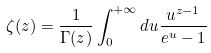<formula> <loc_0><loc_0><loc_500><loc_500>\zeta ( z ) = \frac { 1 } { \Gamma ( z ) } \int _ { 0 } ^ { + \infty } d u \frac { u ^ { z - 1 } } { e ^ { u } - 1 }</formula> 